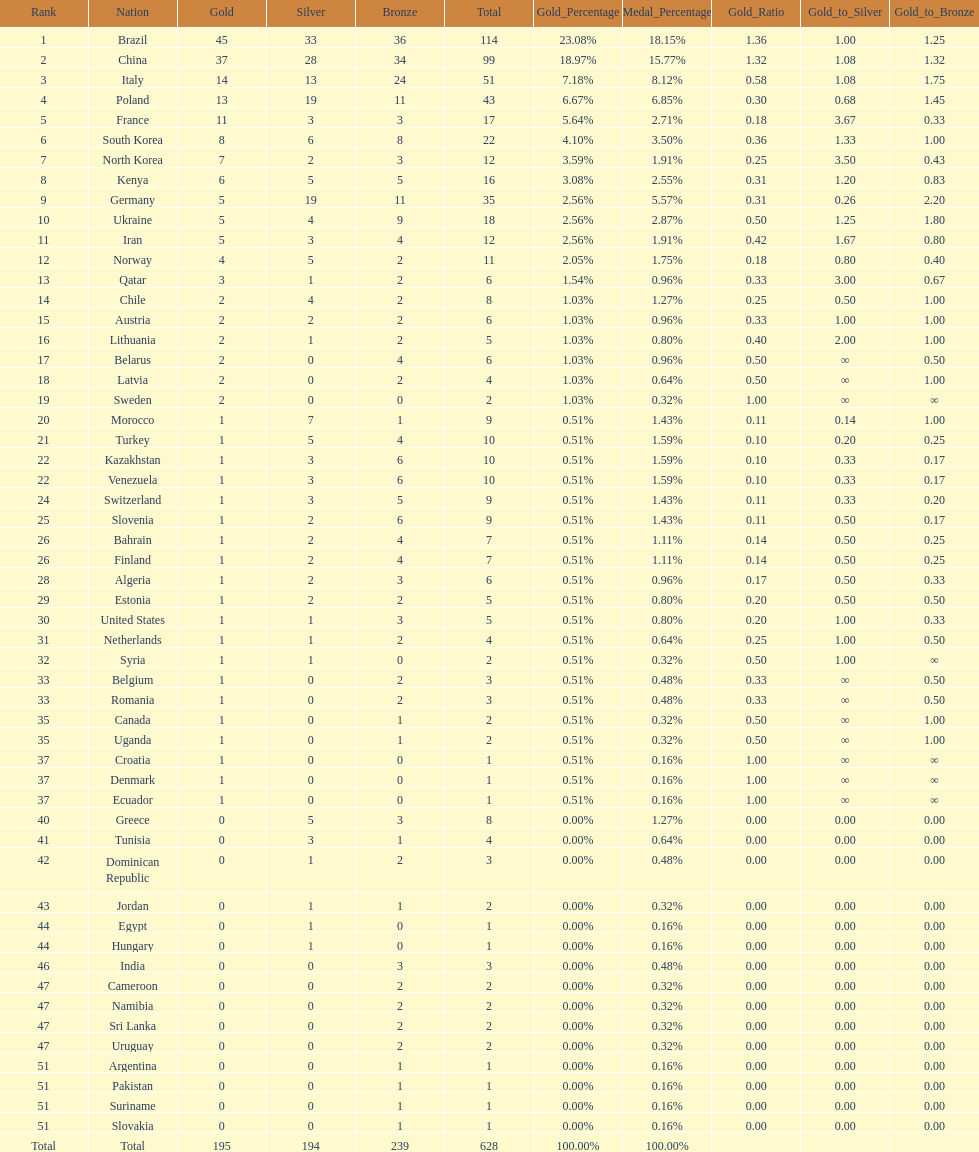Which type of medal does belarus not have? Silver. 